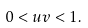Convert formula to latex. <formula><loc_0><loc_0><loc_500><loc_500>0 < u v < 1 .</formula> 